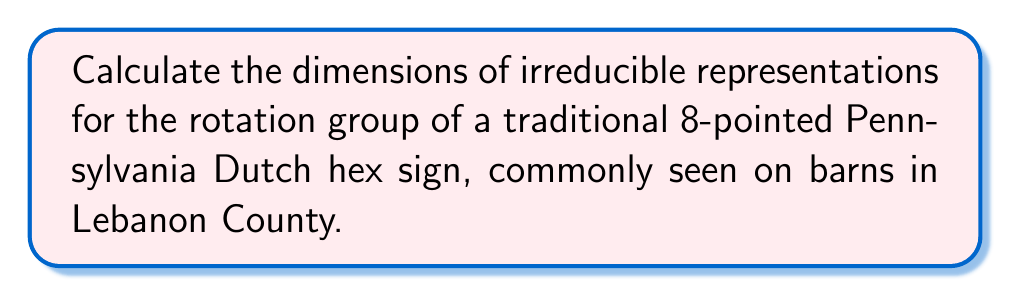Show me your answer to this math problem. Let's approach this step-by-step:

1) The rotation group of an 8-pointed star is isomorphic to the cyclic group $C_8$, which has 8 elements.

2) For cyclic groups, the number of irreducible representations is equal to the number of conjugacy classes, which is equal to the number of elements in the group. So, we have 8 irreducible representations.

3) The irreducible representations of $C_8$ are all one-dimensional, given by:

   $$\rho_k(r) = e^{2\pi i k/8}$$

   where $r$ is the generator of $C_8$ (rotation by $45^\circ$) and $k = 0, 1, 2, ..., 7$.

4) To visualize this, we can think of the hex sign rotating in $45^\circ$ increments, just like the Chix players used to run around the basketball court.

5) The character table for $C_8$ would look like this:

   $$\begin{array}{c|cccccccc}
   C_8 & e & r & r^2 & r^3 & r^4 & r^5 & r^6 & r^7 \\
   \hline
   \rho_0 & 1 & 1 & 1 & 1 & 1 & 1 & 1 & 1 \\
   \rho_1 & 1 & \zeta & \zeta^2 & \zeta^3 & \zeta^4 & \zeta^5 & \zeta^6 & \zeta^7 \\
   \rho_2 & 1 & \zeta^2 & \zeta^4 & \zeta^6 & 1 & \zeta^2 & \zeta^4 & \zeta^6 \\
   \vdots & \vdots & \vdots & \vdots & \vdots & \vdots & \vdots & \vdots & \vdots \\
   \rho_7 & 1 & \zeta^7 & \zeta^6 & \zeta^5 & \zeta^4 & \zeta^3 & \zeta^2 & \zeta
   \end{array}$$

   where $\zeta = e^{2\pi i/8} = \cos(\pi/4) + i\sin(\pi/4)$.

6) Each row in this table represents an irreducible representation, and each entry in the row is the character (trace) of the representation for that group element.

7) Since all entries in the character table are complex numbers, the dimension of each irreducible representation is 1.
Answer: 1-dimensional for all 8 irreducible representations 